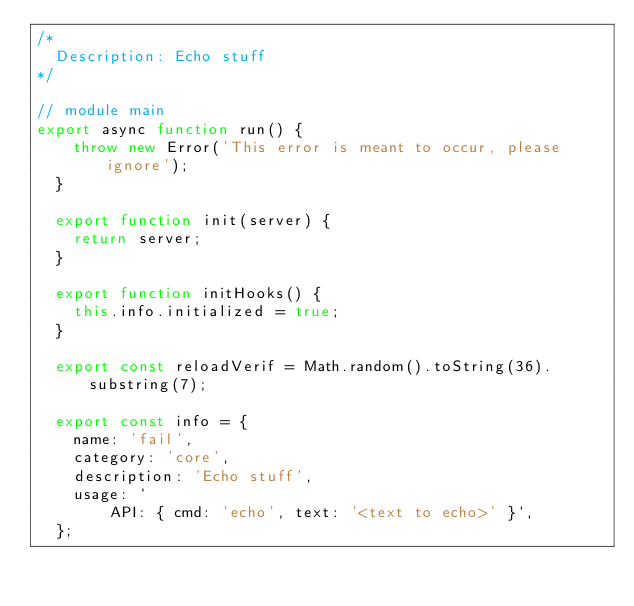<code> <loc_0><loc_0><loc_500><loc_500><_JavaScript_>/*
  Description: Echo stuff
*/

// module main
export async function run() {
    throw new Error('This error is meant to occur, please ignore');
  }
  
  export function init(server) {
    return server;
  }
  
  export function initHooks() {
    this.info.initialized = true;
  }
  
  export const reloadVerif = Math.random().toString(36).substring(7);
  
  export const info = {
    name: 'fail',
    category: 'core',
    description: 'Echo stuff',
    usage: `
        API: { cmd: 'echo', text: '<text to echo>' }`,
  };
  </code> 